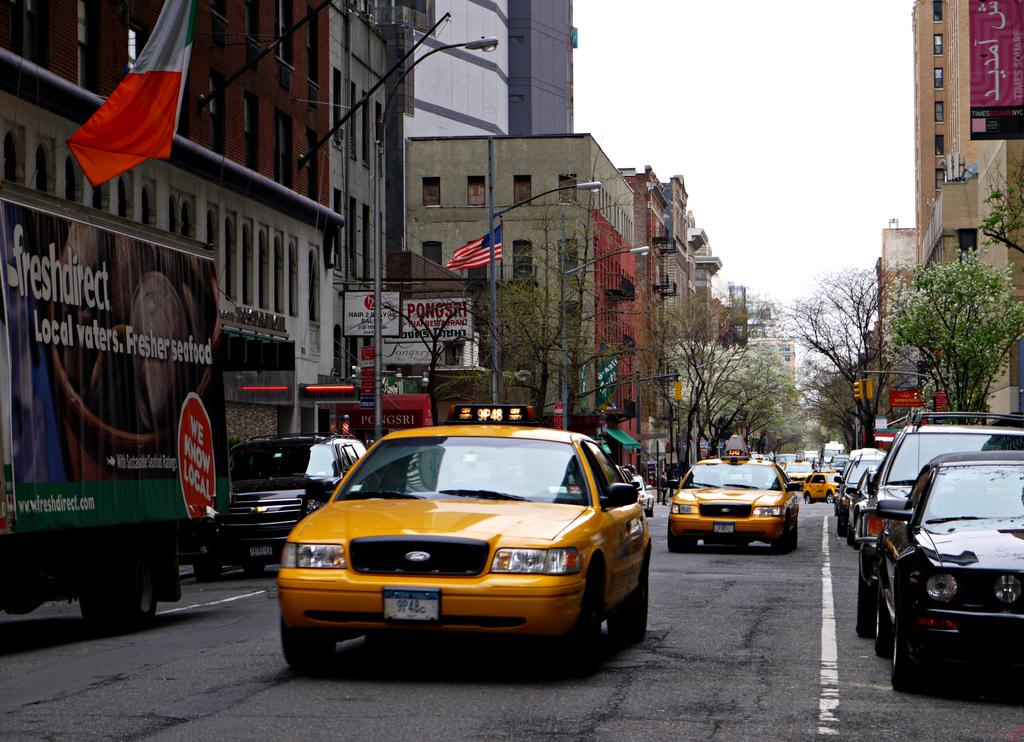<image>
Relay a brief, clear account of the picture shown. A taxi drives past a local seafood truck. 